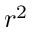Convert formula to latex. <formula><loc_0><loc_0><loc_500><loc_500>r ^ { 2 }</formula> 